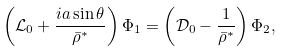<formula> <loc_0><loc_0><loc_500><loc_500>\left ( { \mathcal { L } _ { 0 } + \frac { i a \sin \theta } { \bar { \rho } ^ { * } } } \right ) \Phi _ { 1 } = \left ( { \mathcal { D } _ { 0 } - \frac { 1 } { \bar { \rho } ^ { * } } } \right ) \Phi _ { 2 } ,</formula> 